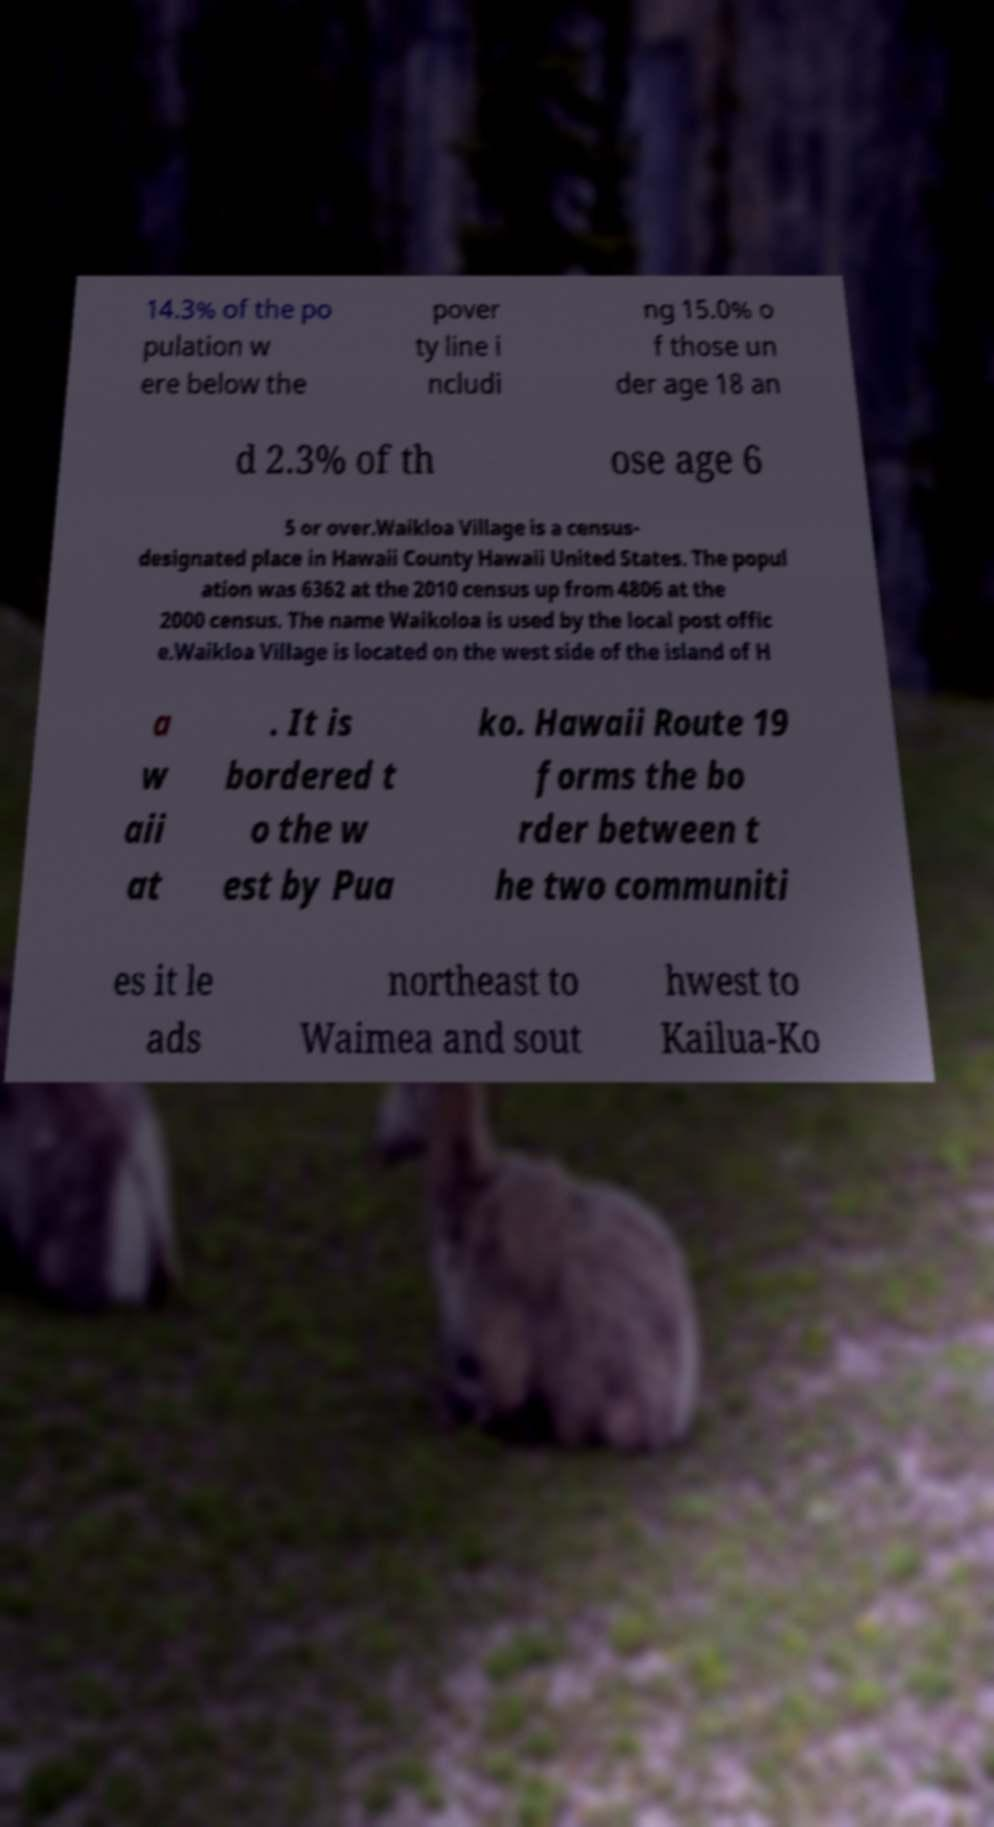What messages or text are displayed in this image? I need them in a readable, typed format. 14.3% of the po pulation w ere below the pover ty line i ncludi ng 15.0% o f those un der age 18 an d 2.3% of th ose age 6 5 or over.Waikloa Village is a census- designated place in Hawaii County Hawaii United States. The popul ation was 6362 at the 2010 census up from 4806 at the 2000 census. The name Waikoloa is used by the local post offic e.Waikloa Village is located on the west side of the island of H a w aii at . It is bordered t o the w est by Pua ko. Hawaii Route 19 forms the bo rder between t he two communiti es it le ads northeast to Waimea and sout hwest to Kailua-Ko 